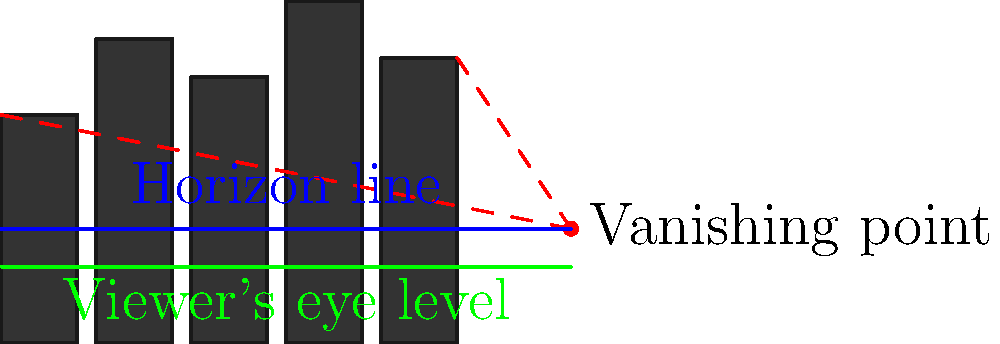In creating a dystopian cityscape for your graphic novel, you want to emphasize a sense of oppression and unease. Which perspective technique should you employ, and how does it relate to the viewer's eye level in this diagram? To create a dystopian atmosphere in a cityscape, we can use perspective techniques to manipulate the viewer's perception. Let's analyze the diagram step-by-step:

1. The diagram shows a cityscape with tall, imposing buildings.
2. There are three key elements in the perspective setup:
   a. The vanishing point (red dot)
   b. The horizon line (blue)
   c. The viewer's eye level (green)

3. In traditional perspective, the viewer's eye level is typically placed at or near the horizon line. However, in this diagram, the viewer's eye level is positioned below the horizon line.

4. This lower eye level creates a low-angle perspective, which has several effects:
   a. It makes the buildings appear taller and more imposing
   b. It creates a sense of the viewer being "small" or "overwhelmed" by the environment
   c. It can evoke feelings of oppression, powerlessness, or being trapped

5. The vanishing point is placed above the viewer's eye level, which further emphasizes the towering nature of the buildings.

6. The perspective lines (red dashed lines) converge at the vanishing point, creating a strong sense of depth and scale.

To create a dystopian atmosphere, you should employ a low-angle perspective by positioning the viewer's eye level below the horizon line. This technique will make the cityscape appear more oppressive and overwhelming, fitting the dystopian theme of your graphic novel.
Answer: Low-angle perspective 